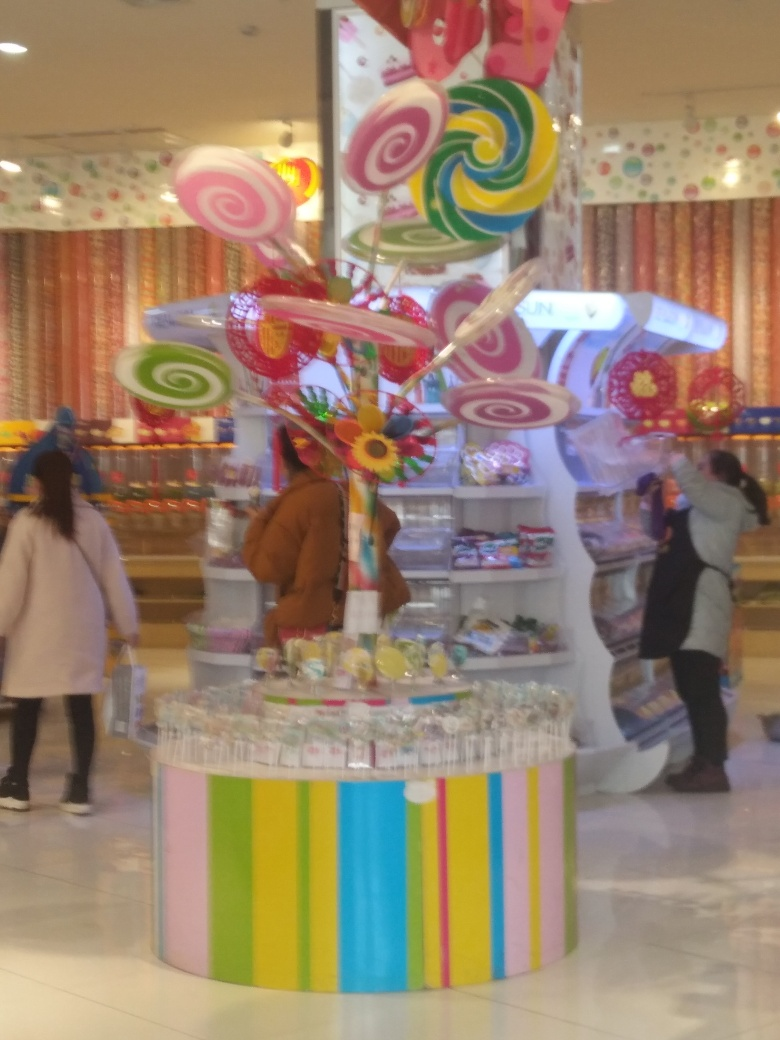How is the lighting in the image? While the image is slightly blurry, which affects the perception of lighting, it appears that the overall lighting within the scene is reasonably balanced and bright, creating a vibrant ambiance around the colorful candy display. 